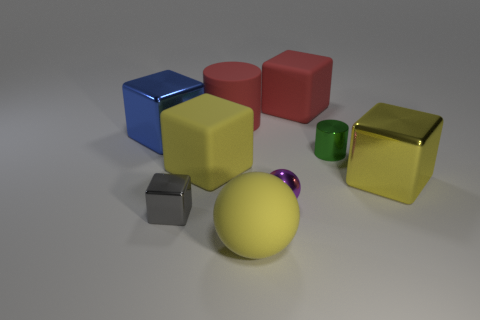Are there any tiny blue metal objects of the same shape as the purple thing?
Ensure brevity in your answer.  No. There is a purple metallic object that is the same size as the gray cube; what shape is it?
Provide a short and direct response. Sphere. What number of other tiny metallic cubes are the same color as the tiny shiny block?
Your response must be concise. 0. There is a metallic block that is in front of the large yellow metal object; how big is it?
Make the answer very short. Small. How many blue metal blocks are the same size as the green cylinder?
Make the answer very short. 0. The ball that is made of the same material as the large red cylinder is what color?
Your answer should be compact. Yellow. Are there fewer metal cylinders in front of the big yellow metal thing than big yellow things?
Your answer should be compact. Yes. There is a tiny gray thing that is the same material as the small green object; what is its shape?
Your answer should be very brief. Cube. How many shiny objects are purple balls or large yellow objects?
Offer a very short reply. 2. Is the number of purple objects to the right of the small purple metal thing the same as the number of large yellow matte objects?
Provide a succinct answer. No. 